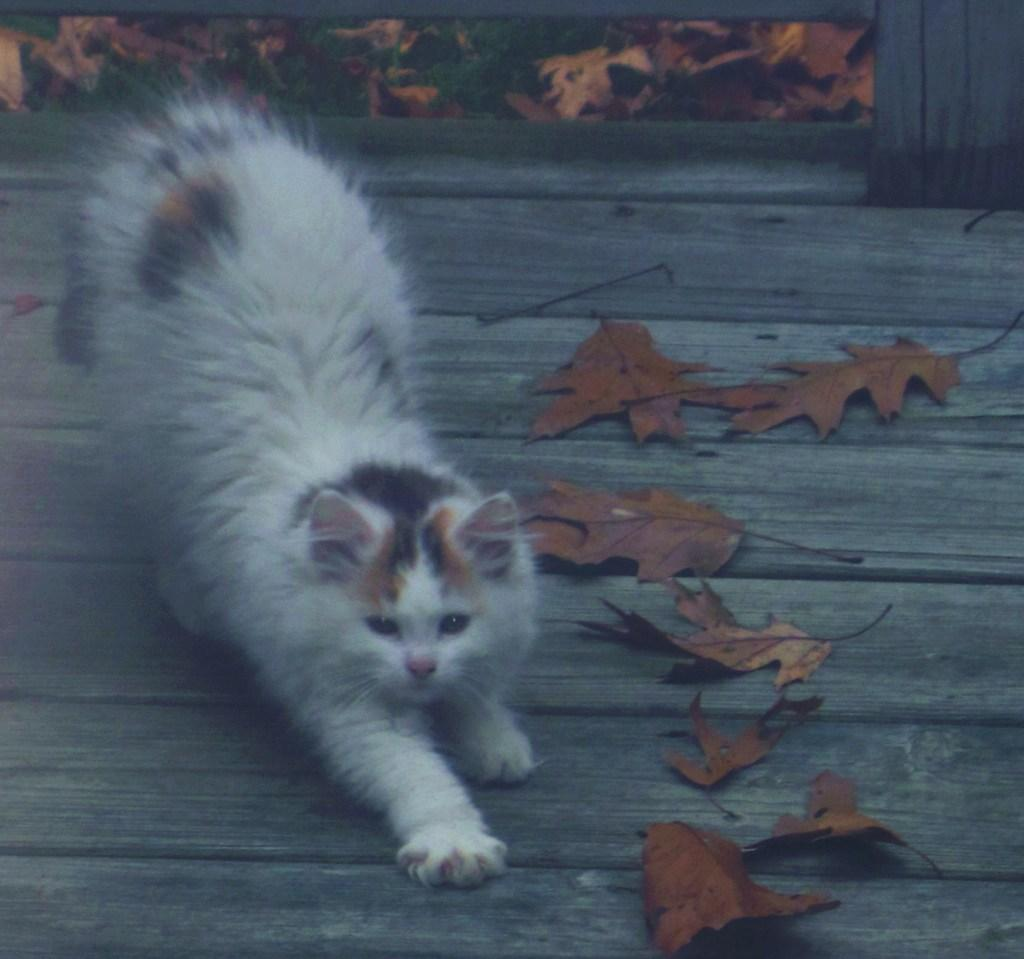What type of animal is in the image? There is a cat in the image. Where is the cat located in the image? The cat is on the left side of the image. What else can be seen in the image besides the cat? There are leaves in the image. How many rings are stacked on the cat's tail in the image? There are no rings present on the cat's tail in the image. 